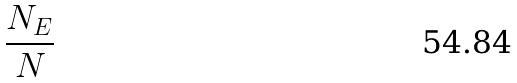Convert formula to latex. <formula><loc_0><loc_0><loc_500><loc_500>\frac { N _ { E } } { N }</formula> 